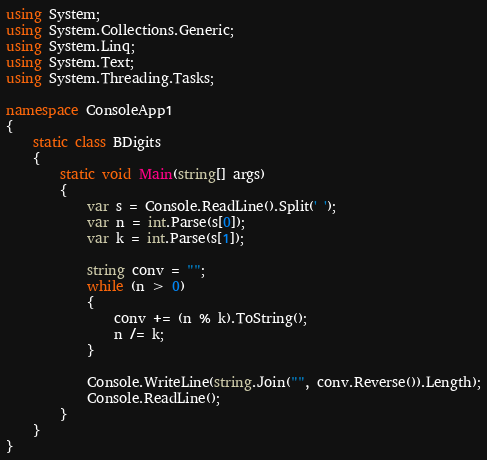Convert code to text. <code><loc_0><loc_0><loc_500><loc_500><_C#_>using System;
using System.Collections.Generic;
using System.Linq;
using System.Text;
using System.Threading.Tasks;

namespace ConsoleApp1
{
    static class BDigits
    {
        static void Main(string[] args)
        {
            var s = Console.ReadLine().Split(' ');
            var n = int.Parse(s[0]);
            var k = int.Parse(s[1]);

            string conv = "";
            while (n > 0)
            {
                conv += (n % k).ToString();
                n /= k;
            }

            Console.WriteLine(string.Join("", conv.Reverse()).Length);
            Console.ReadLine();
        }
    }
}</code> 